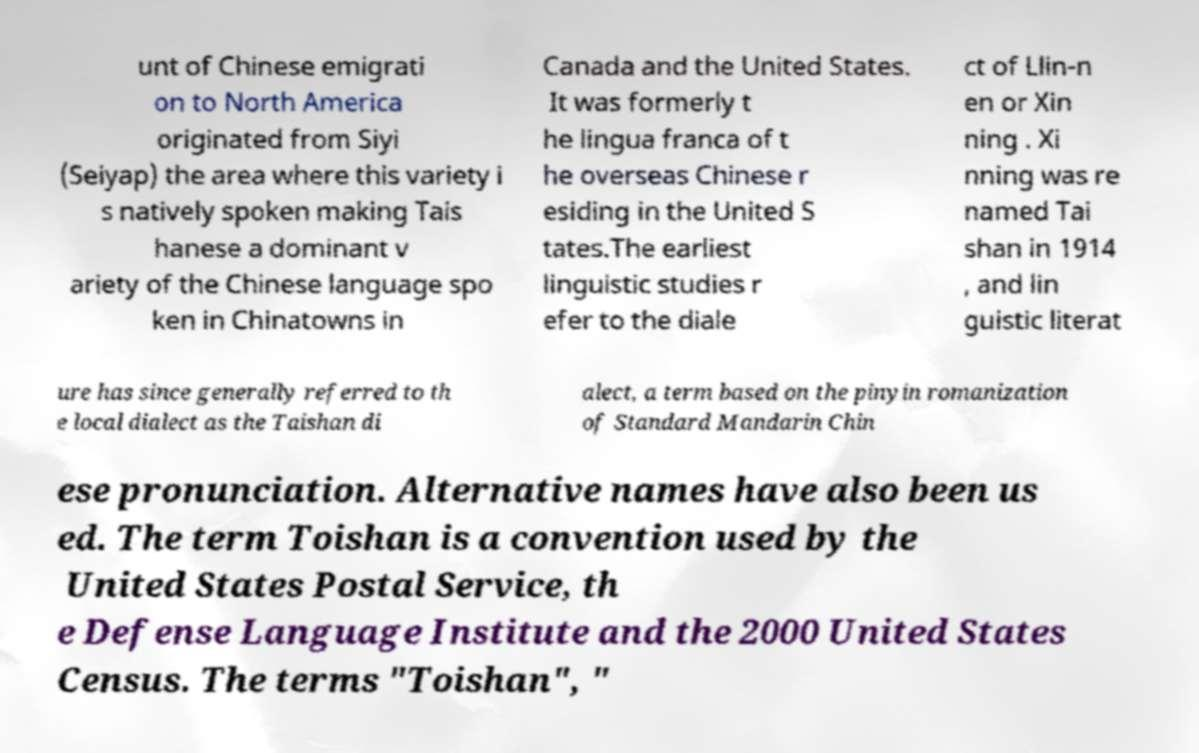Please read and relay the text visible in this image. What does it say? unt of Chinese emigrati on to North America originated from Siyi (Seiyap) the area where this variety i s natively spoken making Tais hanese a dominant v ariety of the Chinese language spo ken in Chinatowns in Canada and the United States. It was formerly t he lingua franca of t he overseas Chinese r esiding in the United S tates.The earliest linguistic studies r efer to the diale ct of Llin-n en or Xin ning . Xi nning was re named Tai shan in 1914 , and lin guistic literat ure has since generally referred to th e local dialect as the Taishan di alect, a term based on the pinyin romanization of Standard Mandarin Chin ese pronunciation. Alternative names have also been us ed. The term Toishan is a convention used by the United States Postal Service, th e Defense Language Institute and the 2000 United States Census. The terms "Toishan", " 